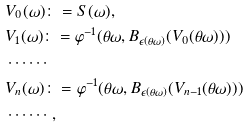Convert formula to latex. <formula><loc_0><loc_0><loc_500><loc_500>& V _ { 0 } ( \omega ) \colon = S ( \omega ) , \\ & V _ { 1 } ( \omega ) \colon = \varphi ^ { - 1 } ( \theta \omega , B _ { \epsilon ( \theta \omega ) } ( V _ { 0 } ( \theta \omega ) ) ) \\ & \cdots \cdots \\ & V _ { n } ( \omega ) \colon = \varphi ^ { - 1 } ( \theta \omega , B _ { \epsilon ( \theta \omega ) } ( V _ { n - 1 } ( \theta \omega ) ) ) \\ & \cdots \cdots ,</formula> 